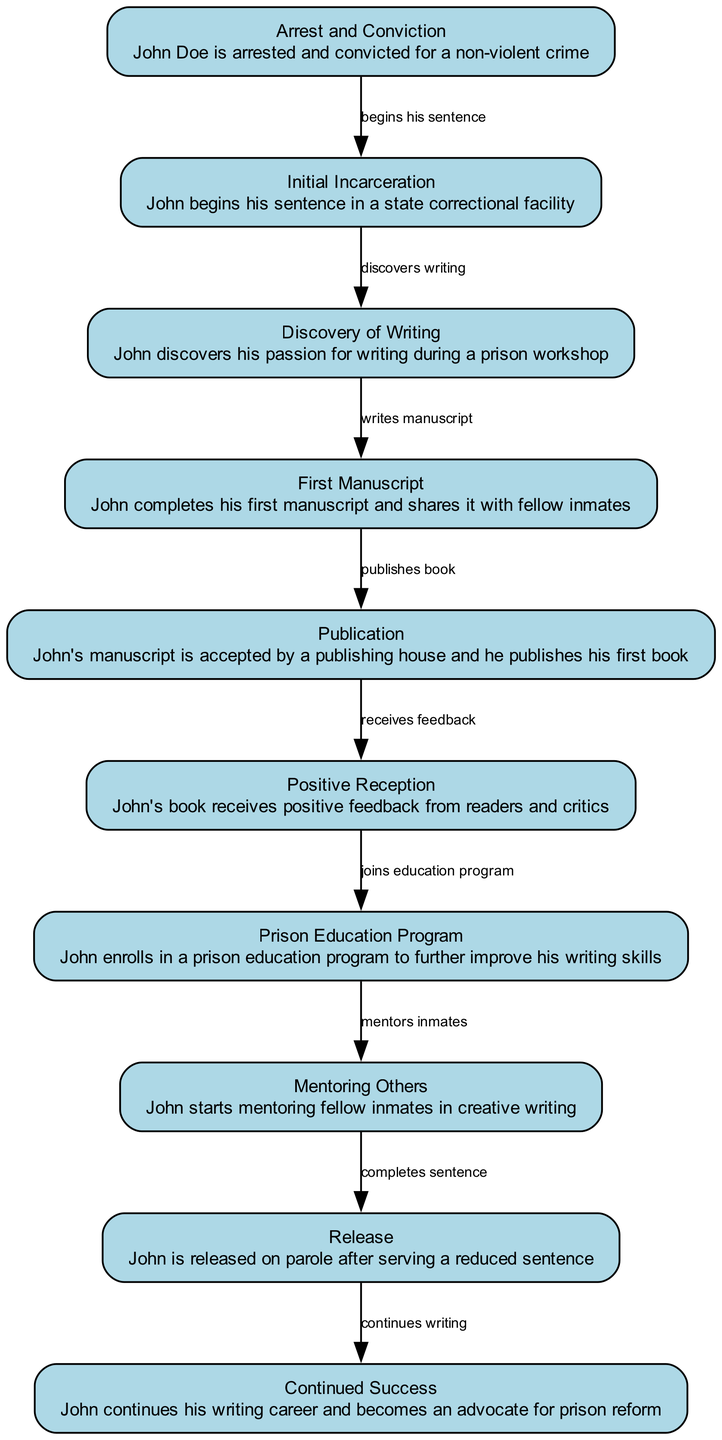What is the first event in John Doe's timeline? The first event listed in the diagram is "Arrest and Conviction," indicating that John Doe was arrested and convicted for a non-violent crime.
Answer: Arrest and Conviction How many nodes are in the diagram? The diagram lists a total of 10 distinct events or milestones, which are represented as nodes.
Answer: 10 What does John discover during his time in incarceration? According to the diagram, during his incarceration, John discovers his passion for writing during a prison workshop.
Answer: Passion for writing What is the direct relationship between the "First Manuscript" and "Publication"? The diagram shows that John completes his first manuscript, which is then accepted by a publishing house and published as his first book, indicating a clear flow from writing to publication.
Answer: Publishes book What milestone occurs right after John's book receives positive feedback? After John's book receives positive feedback, the next step in the timeline shows that he enrolls in a prison education program to further improve his writing skills.
Answer: Joins education program What role does John take after mentoring inmates? After mentoring fellow inmates in creative writing, the diagram shows that he completes his sentence and is subsequently released on parole, suggesting his mentoring role is followed by his release.
Answer: Completes sentence What is the final achievement listed in John's success story? The last event in John's timeline is "Continued Success," which states that he continues his writing career and becomes an advocate for prison reform, indicating ongoing achievements post-release.
Answer: Continued Success What is the connection between John's positive reception and his education? The diagram illustrates that after John receives positive feedback on his book, he joins a prison education program, suggesting that the recognition of his work inspires further personal growth in writing.
Answer: Joins education program 